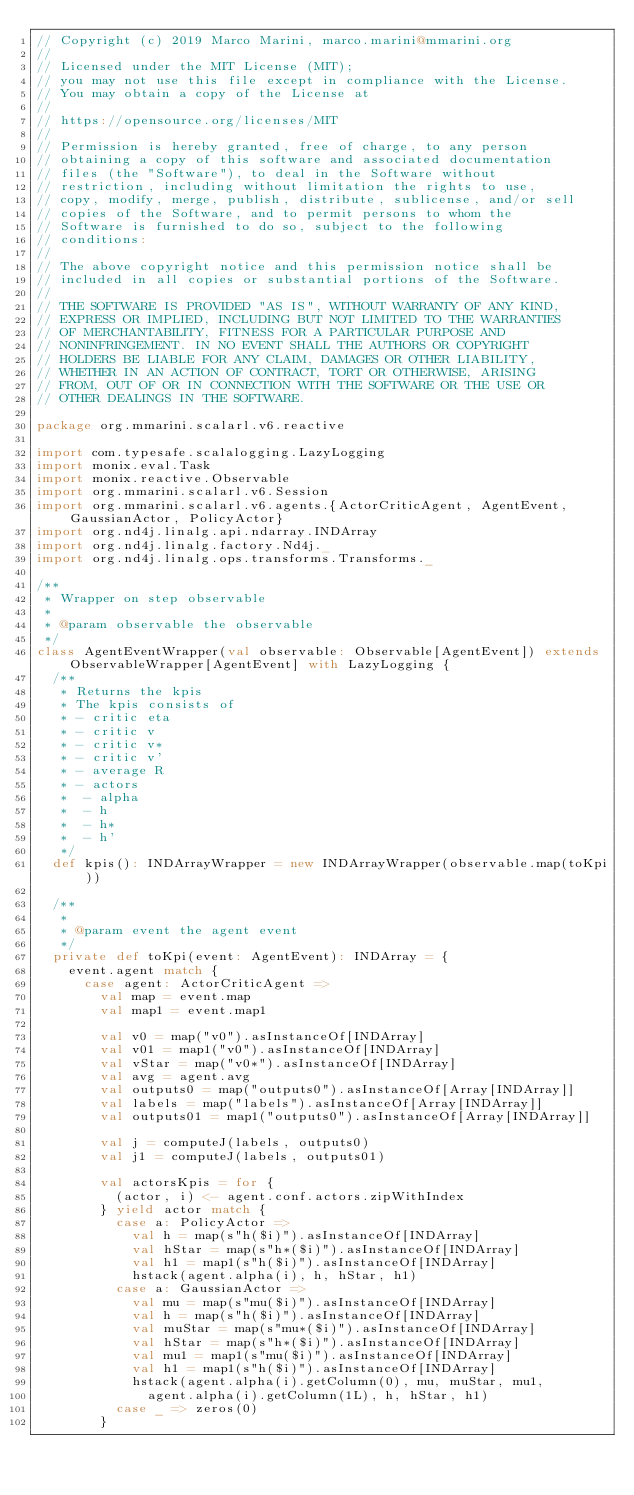<code> <loc_0><loc_0><loc_500><loc_500><_Scala_>// Copyright (c) 2019 Marco Marini, marco.marini@mmarini.org
//
// Licensed under the MIT License (MIT);
// you may not use this file except in compliance with the License.
// You may obtain a copy of the License at
//
// https://opensource.org/licenses/MIT
//
// Permission is hereby granted, free of charge, to any person
// obtaining a copy of this software and associated documentation
// files (the "Software"), to deal in the Software without
// restriction, including without limitation the rights to use,
// copy, modify, merge, publish, distribute, sublicense, and/or sell
// copies of the Software, and to permit persons to whom the
// Software is furnished to do so, subject to the following
// conditions:
//
// The above copyright notice and this permission notice shall be
// included in all copies or substantial portions of the Software.
//
// THE SOFTWARE IS PROVIDED "AS IS", WITHOUT WARRANTY OF ANY KIND,
// EXPRESS OR IMPLIED, INCLUDING BUT NOT LIMITED TO THE WARRANTIES
// OF MERCHANTABILITY, FITNESS FOR A PARTICULAR PURPOSE AND
// NONINFRINGEMENT. IN NO EVENT SHALL THE AUTHORS OR COPYRIGHT
// HOLDERS BE LIABLE FOR ANY CLAIM, DAMAGES OR OTHER LIABILITY,
// WHETHER IN AN ACTION OF CONTRACT, TORT OR OTHERWISE, ARISING
// FROM, OUT OF OR IN CONNECTION WITH THE SOFTWARE OR THE USE OR
// OTHER DEALINGS IN THE SOFTWARE.

package org.mmarini.scalarl.v6.reactive

import com.typesafe.scalalogging.LazyLogging
import monix.eval.Task
import monix.reactive.Observable
import org.mmarini.scalarl.v6.Session
import org.mmarini.scalarl.v6.agents.{ActorCriticAgent, AgentEvent, GaussianActor, PolicyActor}
import org.nd4j.linalg.api.ndarray.INDArray
import org.nd4j.linalg.factory.Nd4j._
import org.nd4j.linalg.ops.transforms.Transforms._

/**
 * Wrapper on step observable
 *
 * @param observable the observable
 */
class AgentEventWrapper(val observable: Observable[AgentEvent]) extends ObservableWrapper[AgentEvent] with LazyLogging {
  /**
   * Returns the kpis
   * The kpis consists of
   * - critic eta
   * - critic v
   * - critic v*
   * - critic v'
   * - average R
   * - actors
   *  - alpha
   *  - h
   *  - h*
   *  - h'
   */
  def kpis(): INDArrayWrapper = new INDArrayWrapper(observable.map(toKpi))

  /**
   *
   * @param event the agent event
   */
  private def toKpi(event: AgentEvent): INDArray = {
    event.agent match {
      case agent: ActorCriticAgent =>
        val map = event.map
        val map1 = event.map1

        val v0 = map("v0").asInstanceOf[INDArray]
        val v01 = map1("v0").asInstanceOf[INDArray]
        val vStar = map("v0*").asInstanceOf[INDArray]
        val avg = agent.avg
        val outputs0 = map("outputs0").asInstanceOf[Array[INDArray]]
        val labels = map("labels").asInstanceOf[Array[INDArray]]
        val outputs01 = map1("outputs0").asInstanceOf[Array[INDArray]]

        val j = computeJ(labels, outputs0)
        val j1 = computeJ(labels, outputs01)

        val actorsKpis = for {
          (actor, i) <- agent.conf.actors.zipWithIndex
        } yield actor match {
          case a: PolicyActor =>
            val h = map(s"h($i)").asInstanceOf[INDArray]
            val hStar = map(s"h*($i)").asInstanceOf[INDArray]
            val h1 = map1(s"h($i)").asInstanceOf[INDArray]
            hstack(agent.alpha(i), h, hStar, h1)
          case a: GaussianActor =>
            val mu = map(s"mu($i)").asInstanceOf[INDArray]
            val h = map(s"h($i)").asInstanceOf[INDArray]
            val muStar = map(s"mu*($i)").asInstanceOf[INDArray]
            val hStar = map(s"h*($i)").asInstanceOf[INDArray]
            val mu1 = map1(s"mu($i)").asInstanceOf[INDArray]
            val h1 = map1(s"h($i)").asInstanceOf[INDArray]
            hstack(agent.alpha(i).getColumn(0), mu, muStar, mu1,
              agent.alpha(i).getColumn(1L), h, hStar, h1)
          case _ => zeros(0)
        }
</code> 